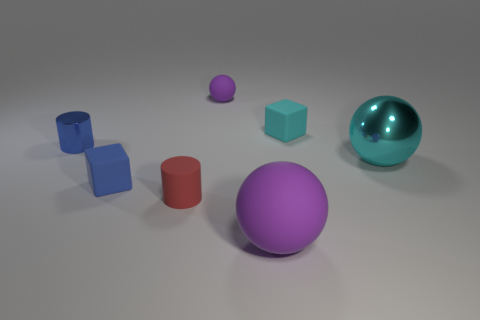Subtract all tiny rubber balls. How many balls are left? 2 Subtract all cyan spheres. How many spheres are left? 2 Add 3 small yellow metallic balls. How many objects exist? 10 Add 1 tiny purple things. How many tiny purple things are left? 2 Add 1 tiny cyan metal cylinders. How many tiny cyan metal cylinders exist? 1 Subtract 0 brown blocks. How many objects are left? 7 Subtract all balls. How many objects are left? 4 Subtract 1 cylinders. How many cylinders are left? 1 Subtract all red spheres. Subtract all gray cylinders. How many spheres are left? 3 Subtract all cyan spheres. How many green cylinders are left? 0 